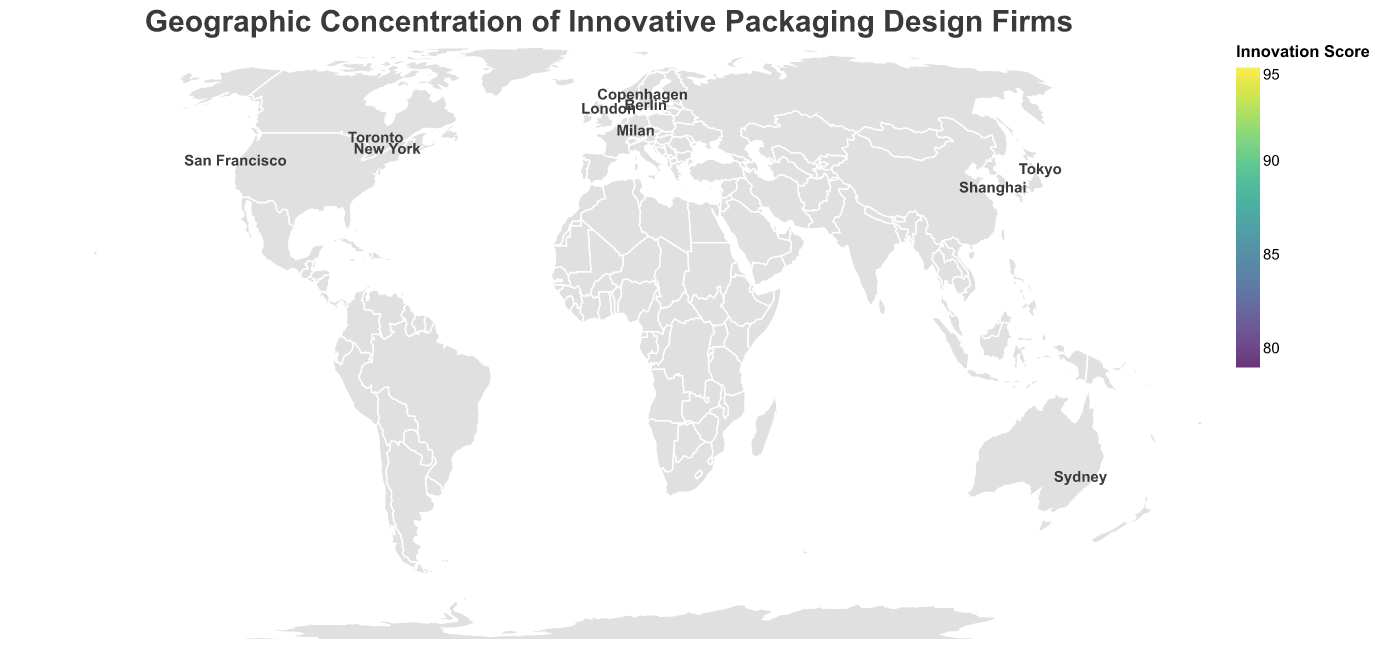Which city has the highest innovation score? The highest innovation score corresponds to the city with the largest circle and the highest numerical value on the color scale. Looking at the largest circle and the highest value, New York has the highest innovation score of 95.
Answer: New York What is the main visual characteristic of San Francisco's data point? San Francisco's data point should be identified on the plot based on its geographic location and visual features. Its circle is relatively large with a score of 88, indicated by the color closer to the higher end of the color scale.
Answer: Large circle with an innovation score of 88 How many cities in the plot have an innovation score higher than 85? Count the circles that have a size and color corresponding to an innovation score greater than 85. These cities are New York (95), London (92), Tokyo (89), San Francisco (88), and Milan (86).
Answer: 5 Which city has the lowest innovation score? The city with the smallest circle and the lightest color on the plot represents the lowest innovation score. From the data provided, Toronto has the lowest innovation score of 79.
Answer: Toronto Compare the innovation scores of Copenhagen and Sydney. Which is higher? Identify both cities on the map by their geographic locations and associated circles. Check the innovation scores from the legend or provided data. Copenhagen has an innovation score of 85, whereas Sydney has 83.
Answer: Copenhagen What is the median innovation score of all the cities plotted? Order the innovation scores: 79, 80, 82, 83, 85, 86, 88, 89, 92, 95. Since there are 10 cities, the median is the average of the 5th and 6th values: (85 + 86)/2 = 85.5.
Answer: 85.5 Which country has two cities represented on the plot? Survey the provided data to find which country appears more than once. The USA has two cities: New York and San Francisco.
Answer: USA Identify the city with the top firm named "Eco-Pack Designs." What is its innovation score? Find the city associated with "Eco-Pack Designs" by checking the tooltip data. This firm is based in Tokyo, which has an innovation score of 89.
Answer: 89 Which city in Europe has the highest innovation score? Locate the European cities on the plot and compare their innovation scores. London has the highest innovation score of 92 among European cities.
Answer: London 